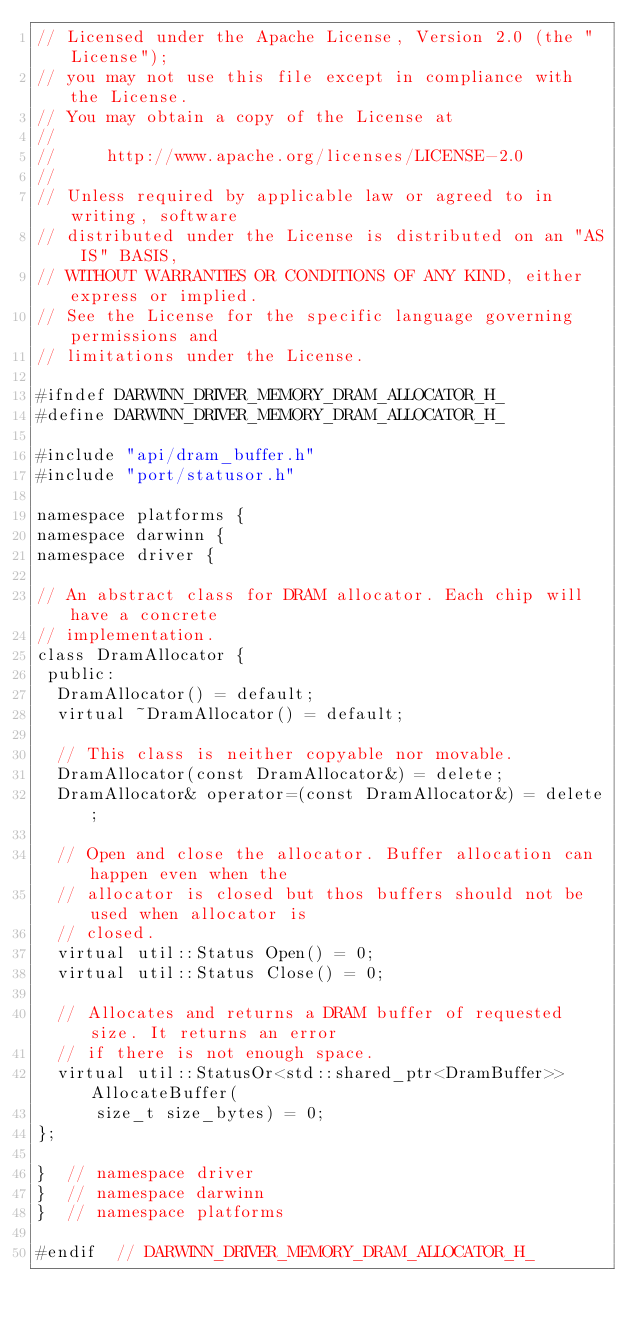Convert code to text. <code><loc_0><loc_0><loc_500><loc_500><_C_>// Licensed under the Apache License, Version 2.0 (the "License");
// you may not use this file except in compliance with the License.
// You may obtain a copy of the License at
//
//     http://www.apache.org/licenses/LICENSE-2.0
//
// Unless required by applicable law or agreed to in writing, software
// distributed under the License is distributed on an "AS IS" BASIS,
// WITHOUT WARRANTIES OR CONDITIONS OF ANY KIND, either express or implied.
// See the License for the specific language governing permissions and
// limitations under the License.

#ifndef DARWINN_DRIVER_MEMORY_DRAM_ALLOCATOR_H_
#define DARWINN_DRIVER_MEMORY_DRAM_ALLOCATOR_H_

#include "api/dram_buffer.h"
#include "port/statusor.h"

namespace platforms {
namespace darwinn {
namespace driver {

// An abstract class for DRAM allocator. Each chip will have a concrete
// implementation.
class DramAllocator {
 public:
  DramAllocator() = default;
  virtual ~DramAllocator() = default;

  // This class is neither copyable nor movable.
  DramAllocator(const DramAllocator&) = delete;
  DramAllocator& operator=(const DramAllocator&) = delete;

  // Open and close the allocator. Buffer allocation can happen even when the
  // allocator is closed but thos buffers should not be used when allocator is
  // closed.
  virtual util::Status Open() = 0;
  virtual util::Status Close() = 0;

  // Allocates and returns a DRAM buffer of requested size. It returns an error
  // if there is not enough space.
  virtual util::StatusOr<std::shared_ptr<DramBuffer>> AllocateBuffer(
      size_t size_bytes) = 0;
};

}  // namespace driver
}  // namespace darwinn
}  // namespace platforms

#endif  // DARWINN_DRIVER_MEMORY_DRAM_ALLOCATOR_H_
</code> 